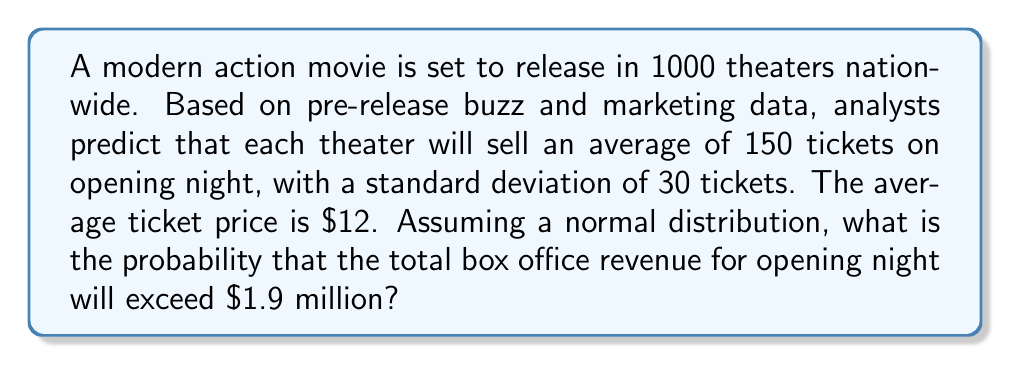Teach me how to tackle this problem. Let's approach this step-by-step:

1) First, we need to calculate the mean total revenue:
   $\mu = 1000 \text{ theaters} \times 150 \text{ tickets} \times \$12 = \$1,800,000$

2) Next, we calculate the standard deviation of the total revenue:
   $\sigma = \sqrt{1000} \times 30 \text{ tickets} \times \$12 = \$11,389.24$

3) We want to find $P(X > 1,900,000)$, where $X$ is the total revenue.

4) We can standardize this to a $z$-score:
   $z = \frac{X - \mu}{\sigma} = \frac{1,900,000 - 1,800,000}{11,389.24} = 8.78$

5) We need to find $P(Z > 8.78)$, where $Z$ is a standard normal variable.

6) Using a standard normal table or calculator, we find:
   $P(Z > 8.78) \approx 0$

7) Therefore, the probability of exceeding $1.9 million is approximately 0.

This extremely low probability suggests that, given the provided statistics, it's highly unlikely for the movie to exceed $1.9 million in opening night revenue. This aligns with the persona's preference for modern cinema, as it provides a data-driven approach to analyzing movie performance.
Answer: $\approx 0$ 